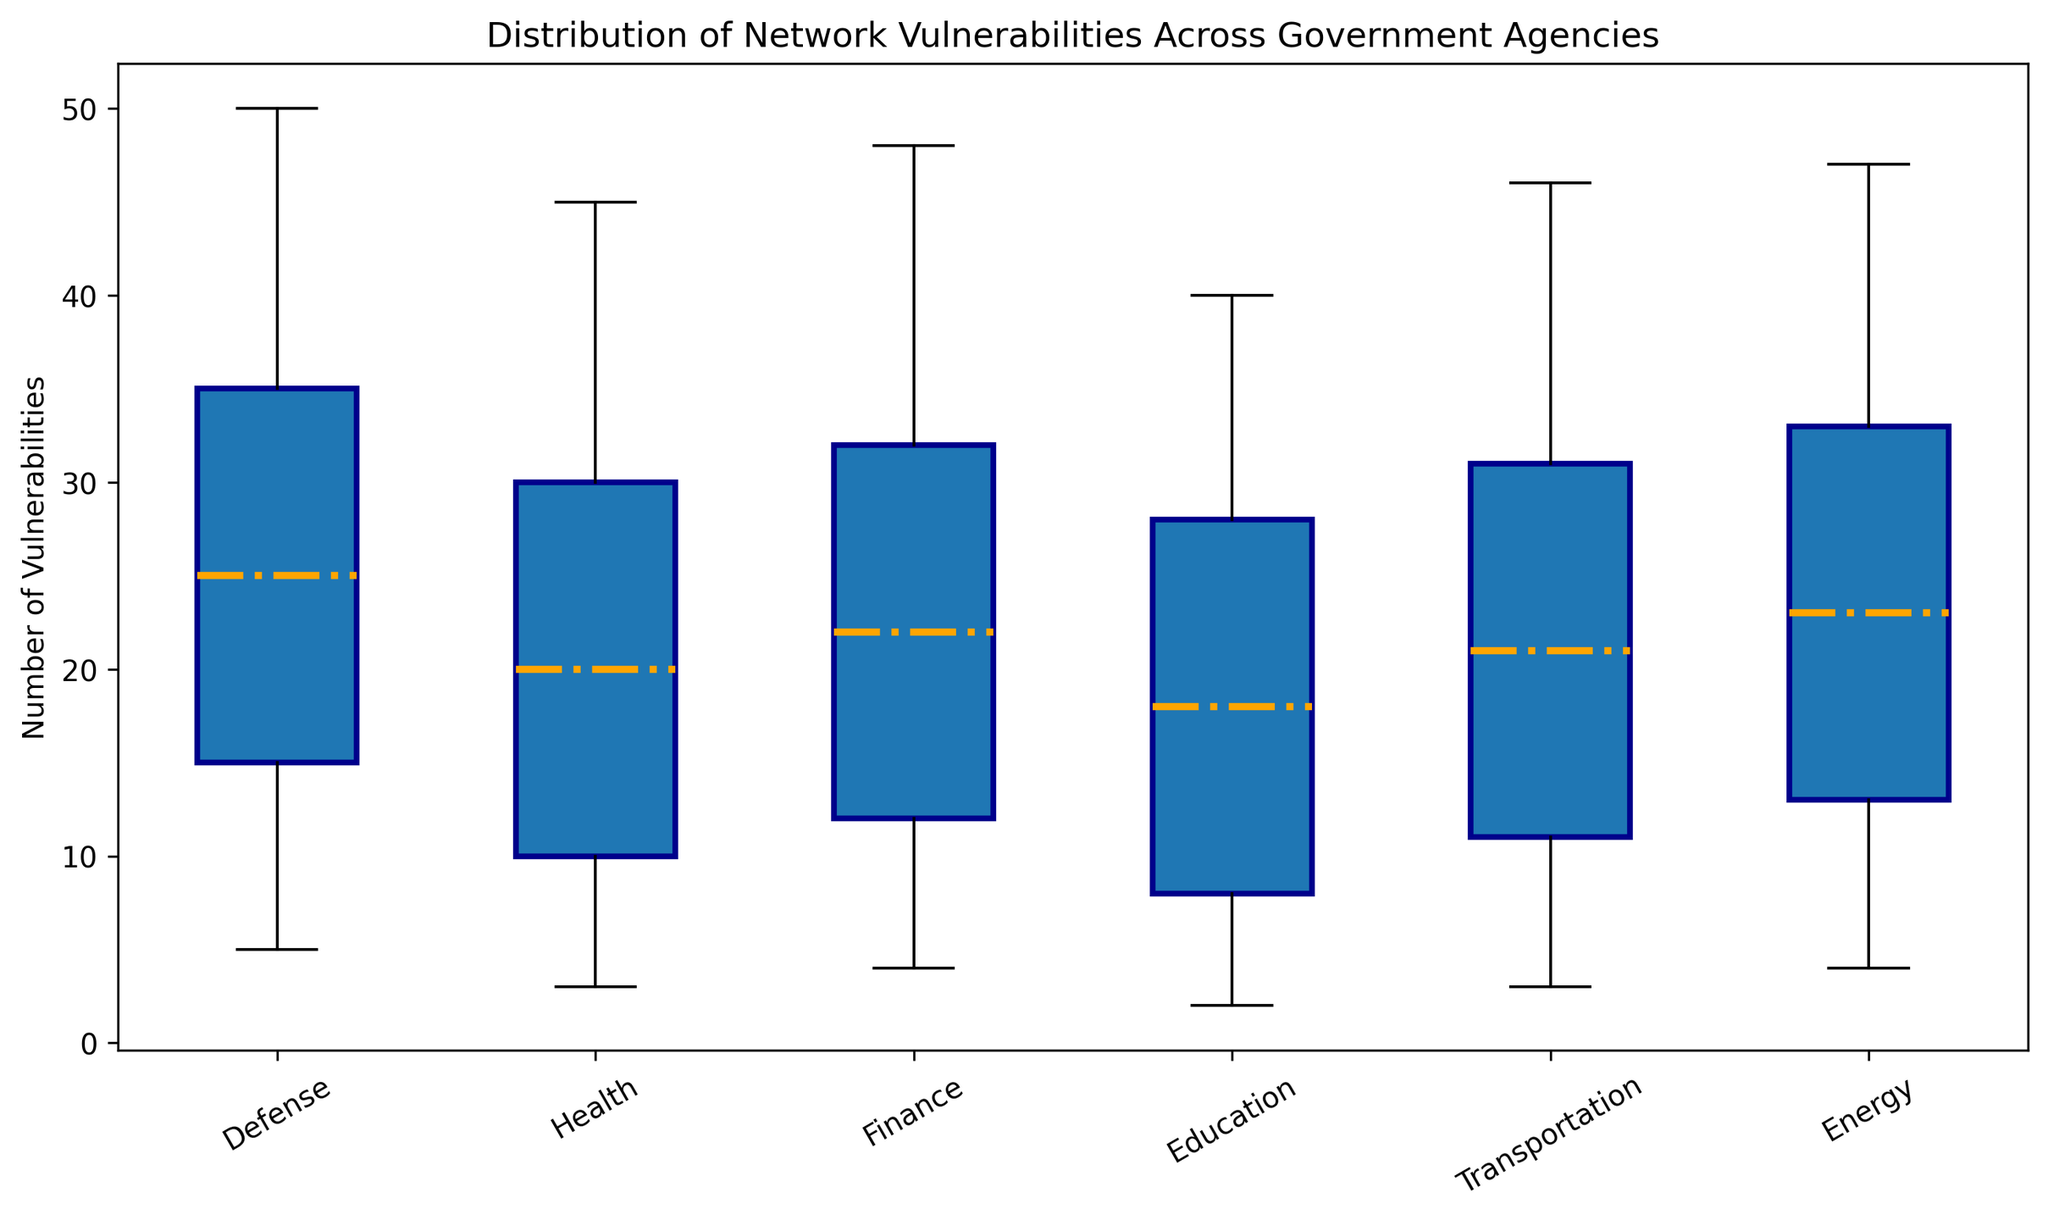What is the median value for the Defense agency? The median value for the Defense agency is directly shown on the box plot's median line for that category.
Answer: 25 Which agency has the smallest minimum value of network vulnerabilities? The minimum value is the lowest point of the vertical line (whisker) for each agency. The Education agency has the smallest minimum value.
Answer: Education Which agency has the largest third quartile value? The third quartile value (Q3) is the top edge of the box. The Defense agency has the largest third quartile value.
Answer: Defense What is the interquartile range (IQR) for the Health agency? The IQR is calculated as the difference between the third quartile (Q3) and the first quartile (Q1). For Health, Q3 is 30 and Q1 is 10. IQR = Q3 - Q1 = 30 - 10.
Answer: 20 Compare the median number of vulnerabilities between Finance and Energy agencies. Which one is higher? The median value is the middle line of the box. The median for Finance is 22 and for Energy is 23. Since 23 is greater than 22, Energy has a higher median.
Answer: Energy What is the total range of vulnerabilities for the Transportation agency? The total range is the difference between the maximum and minimum values. For Transportation, the maximum value is 46 and the minimum is 3. Range = 46 - 3.
Answer: 43 How does the median value of vulnerabilities in the Education agency compare to the Health agency? Visually comparing the median lines, for Education, it is 18, and for Health, it is 20. The Education agency has a lower median.
Answer: Education Which agency has the highest maximum value of vulnerabilities? The highest maximum value is represented by the top whisker. Defense has the highest maximum value of vulnerabilities.
Answer: Defense Are there any agencies with the same median value of vulnerabilities? If so, which ones? By visually inspecting the median lines in each box, no two agencies have the same median value.
Answer: None 